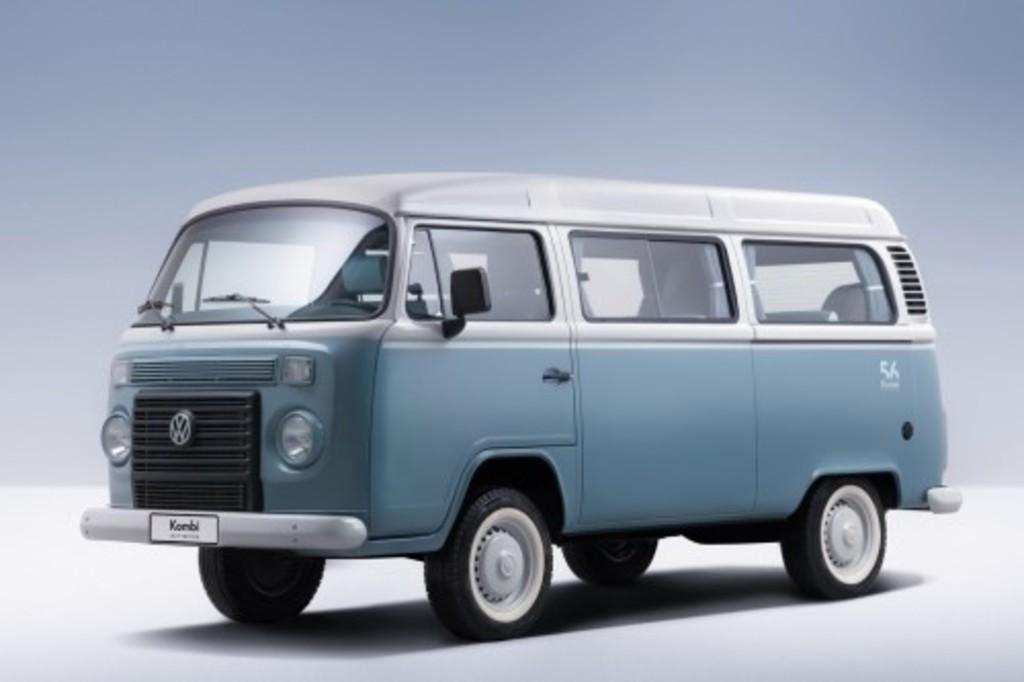<image>
Create a compact narrative representing the image presented. A volkswagon model van with a white roof and blue body with the word Kombi on a bumper sticker. 